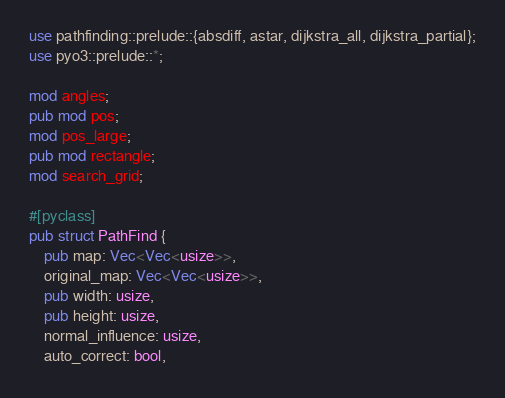<code> <loc_0><loc_0><loc_500><loc_500><_Rust_>use pathfinding::prelude::{absdiff, astar, dijkstra_all, dijkstra_partial};
use pyo3::prelude::*;

mod angles;
pub mod pos;
mod pos_large;
pub mod rectangle;
mod search_grid;

#[pyclass]
pub struct PathFind {
    pub map: Vec<Vec<usize>>,
    original_map: Vec<Vec<usize>>,
    pub width: usize,
    pub height: usize,
    normal_influence: usize,
    auto_correct: bool,</code> 